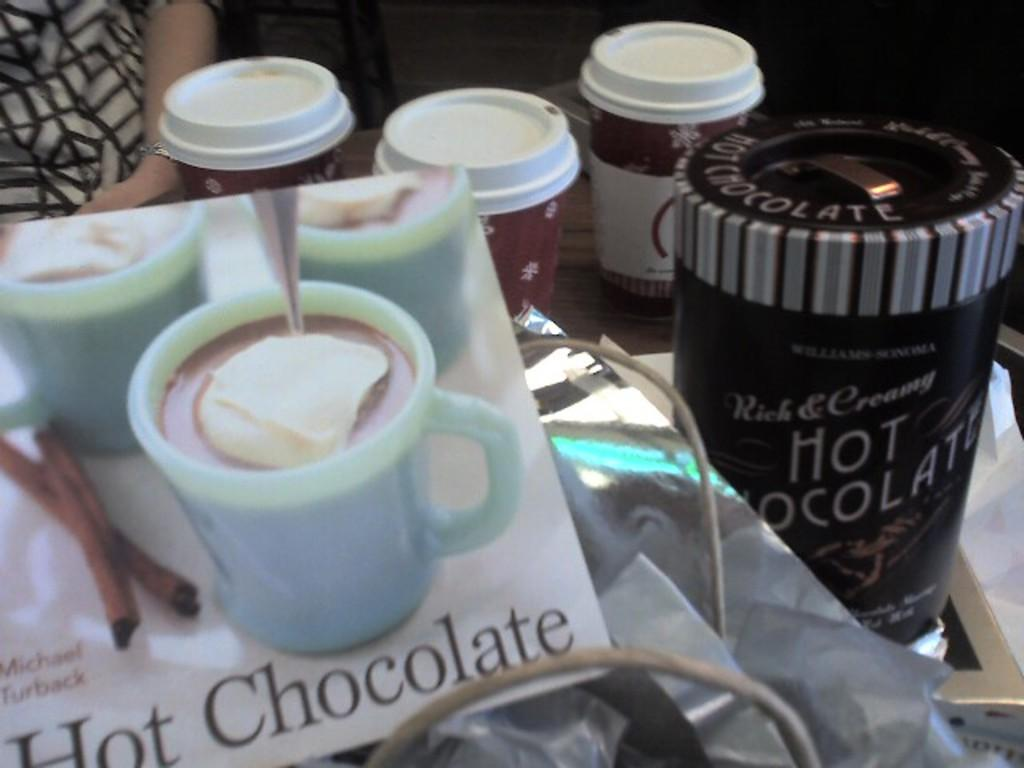What is the main piece of furniture in the image? There is a table in the image. What objects are on the table? There are cups, a box, and papers on the table. What is the person in the image wearing? The person in the image is wearing a white dress. Where is the person in relation to the papers on the table? The person is in front of the papers on the table. What type of straw is being used to stir the jam in the image? There is no jam or straw present in the image. 